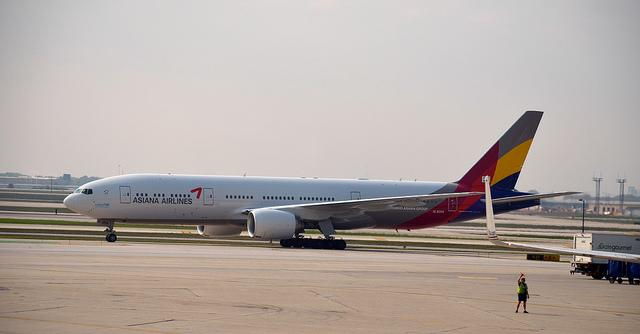Why is the man holding up an orange object? directing traffic 